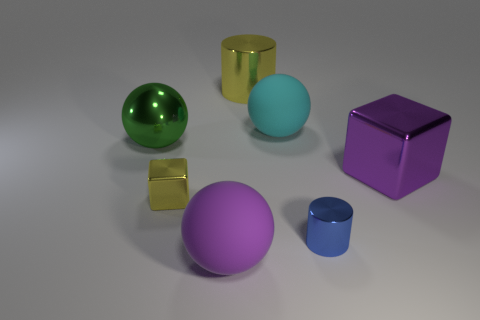The cyan rubber ball is what size?
Ensure brevity in your answer.  Large. Are there more big green shiny objects behind the small block than small cylinders in front of the purple matte ball?
Ensure brevity in your answer.  Yes. How many small blue metallic things are behind the shiny cube that is on the right side of the tiny blue metal cylinder?
Give a very brief answer. 0. There is a big purple object that is in front of the small blue cylinder; is its shape the same as the small blue thing?
Offer a very short reply. No. There is a purple thing that is the same shape as the large cyan object; what is it made of?
Your response must be concise. Rubber. What number of green matte blocks are the same size as the purple shiny object?
Provide a short and direct response. 0. The thing that is right of the large cyan matte thing and behind the tiny yellow thing is what color?
Make the answer very short. Purple. Is the number of large green metal spheres less than the number of large brown cubes?
Give a very brief answer. No. There is a big cylinder; is it the same color as the cube that is on the left side of the yellow cylinder?
Your answer should be very brief. Yes. Is the number of yellow metal objects behind the large yellow metal thing the same as the number of large balls left of the small blue cylinder?
Make the answer very short. No. 